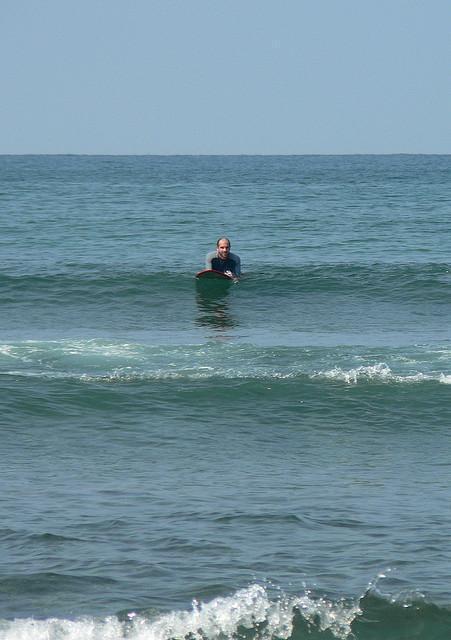How many people are in the water?
Give a very brief answer. 1. 